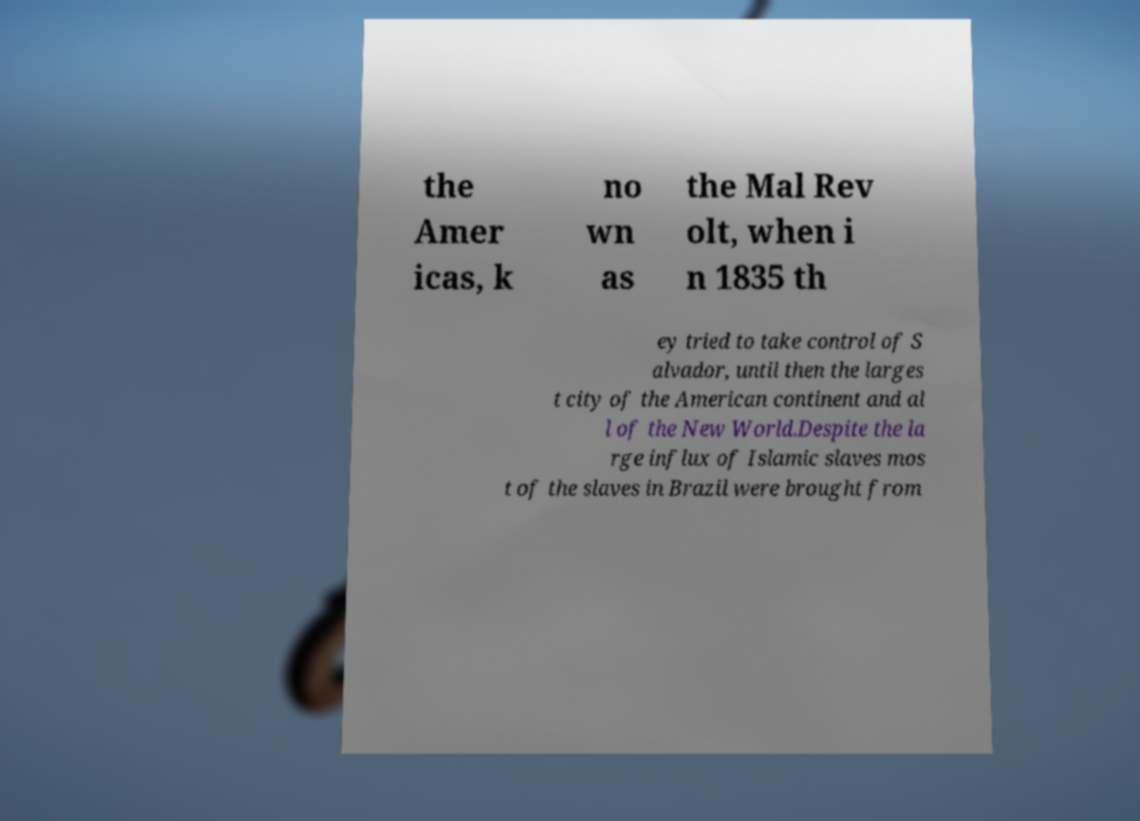What messages or text are displayed in this image? I need them in a readable, typed format. the Amer icas, k no wn as the Mal Rev olt, when i n 1835 th ey tried to take control of S alvador, until then the larges t city of the American continent and al l of the New World.Despite the la rge influx of Islamic slaves mos t of the slaves in Brazil were brought from 